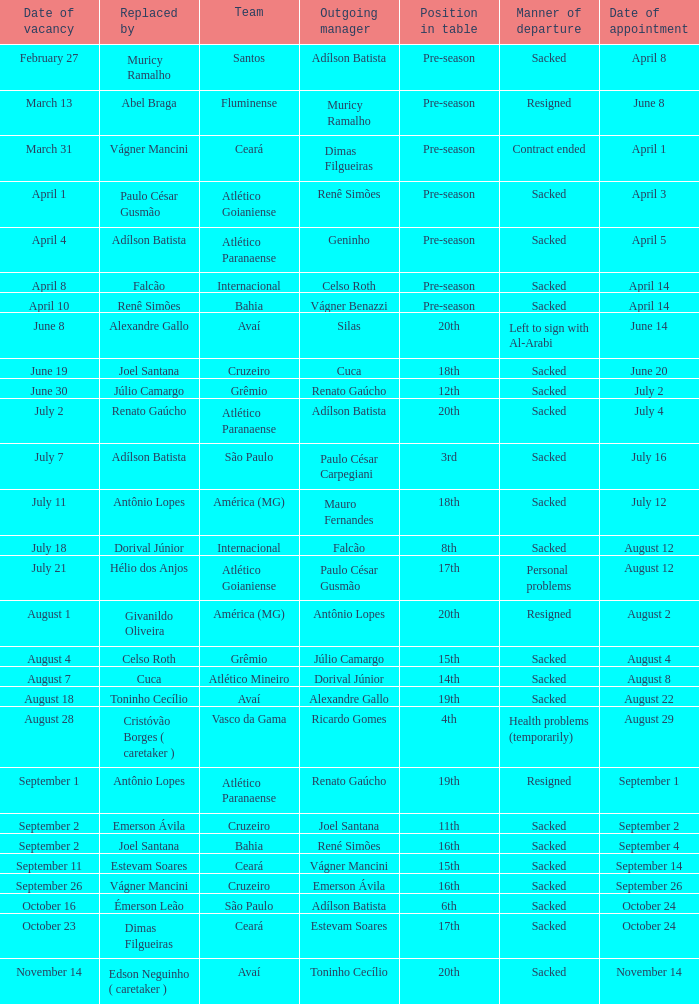Who was the new Santos manager? Muricy Ramalho. Give me the full table as a dictionary. {'header': ['Date of vacancy', 'Replaced by', 'Team', 'Outgoing manager', 'Position in table', 'Manner of departure', 'Date of appointment'], 'rows': [['February 27', 'Muricy Ramalho', 'Santos', 'Adílson Batista', 'Pre-season', 'Sacked', 'April 8'], ['March 13', 'Abel Braga', 'Fluminense', 'Muricy Ramalho', 'Pre-season', 'Resigned', 'June 8'], ['March 31', 'Vágner Mancini', 'Ceará', 'Dimas Filgueiras', 'Pre-season', 'Contract ended', 'April 1'], ['April 1', 'Paulo César Gusmão', 'Atlético Goianiense', 'Renê Simões', 'Pre-season', 'Sacked', 'April 3'], ['April 4', 'Adílson Batista', 'Atlético Paranaense', 'Geninho', 'Pre-season', 'Sacked', 'April 5'], ['April 8', 'Falcão', 'Internacional', 'Celso Roth', 'Pre-season', 'Sacked', 'April 14'], ['April 10', 'Renê Simões', 'Bahia', 'Vágner Benazzi', 'Pre-season', 'Sacked', 'April 14'], ['June 8', 'Alexandre Gallo', 'Avaí', 'Silas', '20th', 'Left to sign with Al-Arabi', 'June 14'], ['June 19', 'Joel Santana', 'Cruzeiro', 'Cuca', '18th', 'Sacked', 'June 20'], ['June 30', 'Júlio Camargo', 'Grêmio', 'Renato Gaúcho', '12th', 'Sacked', 'July 2'], ['July 2', 'Renato Gaúcho', 'Atlético Paranaense', 'Adílson Batista', '20th', 'Sacked', 'July 4'], ['July 7', 'Adílson Batista', 'São Paulo', 'Paulo César Carpegiani', '3rd', 'Sacked', 'July 16'], ['July 11', 'Antônio Lopes', 'América (MG)', 'Mauro Fernandes', '18th', 'Sacked', 'July 12'], ['July 18', 'Dorival Júnior', 'Internacional', 'Falcão', '8th', 'Sacked', 'August 12'], ['July 21', 'Hélio dos Anjos', 'Atlético Goianiense', 'Paulo César Gusmão', '17th', 'Personal problems', 'August 12'], ['August 1', 'Givanildo Oliveira', 'América (MG)', 'Antônio Lopes', '20th', 'Resigned', 'August 2'], ['August 4', 'Celso Roth', 'Grêmio', 'Júlio Camargo', '15th', 'Sacked', 'August 4'], ['August 7', 'Cuca', 'Atlético Mineiro', 'Dorival Júnior', '14th', 'Sacked', 'August 8'], ['August 18', 'Toninho Cecílio', 'Avaí', 'Alexandre Gallo', '19th', 'Sacked', 'August 22'], ['August 28', 'Cristóvão Borges ( caretaker )', 'Vasco da Gama', 'Ricardo Gomes', '4th', 'Health problems (temporarily)', 'August 29'], ['September 1', 'Antônio Lopes', 'Atlético Paranaense', 'Renato Gaúcho', '19th', 'Resigned', 'September 1'], ['September 2', 'Emerson Ávila', 'Cruzeiro', 'Joel Santana', '11th', 'Sacked', 'September 2'], ['September 2', 'Joel Santana', 'Bahia', 'René Simões', '16th', 'Sacked', 'September 4'], ['September 11', 'Estevam Soares', 'Ceará', 'Vágner Mancini', '15th', 'Sacked', 'September 14'], ['September 26', 'Vágner Mancini', 'Cruzeiro', 'Emerson Ávila', '16th', 'Sacked', 'September 26'], ['October 16', 'Émerson Leão', 'São Paulo', 'Adílson Batista', '6th', 'Sacked', 'October 24'], ['October 23', 'Dimas Filgueiras', 'Ceará', 'Estevam Soares', '17th', 'Sacked', 'October 24'], ['November 14', 'Edson Neguinho ( caretaker )', 'Avaí', 'Toninho Cecílio', '20th', 'Sacked', 'November 14']]} 